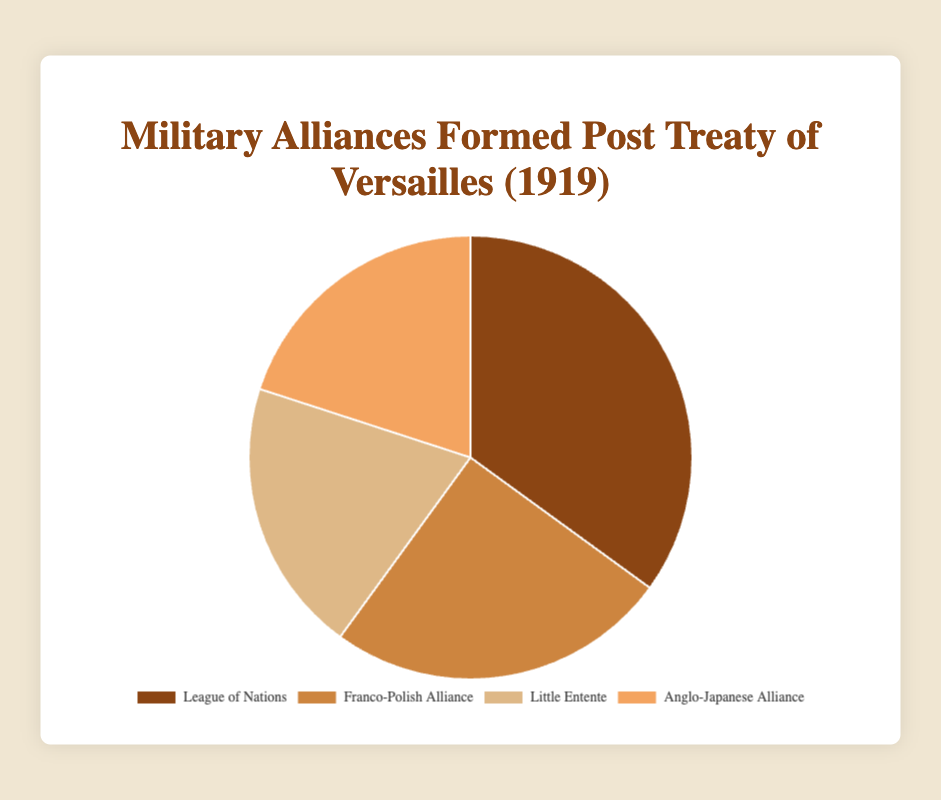What were the four military alliances formed post-Treaty of Versailles? The pie chart displays four alliances: League of Nations, Franco-Polish Alliance, Little Entente, and Anglo-Japanese Alliance, hence identifying the four alliances formed.
Answer: League of Nations, Franco-Polish Alliance, Little Entente, Anglo-Japanese Alliance Which alliance had the highest percentage of formations post-Treaty of Versailles? The largest section of the pie chart is for the League of Nations, indicated by the biggest segment in the pie chart.
Answer: League of Nations How did the percentages of Franco-Polish Alliance and Little Entente compare to each other? By looking at the pie chart, the segments for Franco-Polish Alliance and Little Entente show that Franco-Polish Alliance formed 25%, which is larger than Little Entente's 20%.
Answer: Franco-Polish Alliance was greater than Little Entente What is the combined percentage of the smaller alliances formed post-Treaty of Versailles? Summing the percentages of Little Entente and Anglo-Japanese Alliance (20% + 20%), which are the smaller segments, gives a combined percentage.
Answer: 40% How does the size of the League of Nations' segment visually differ from the Anglo-Japanese Alliance's segment? The segment for the League of Nations is larger than the Anglo-Japanese Alliance, indicating a higher percentage (35% compared to 20%).
Answer: The League of Nations' segment is larger Which two alliances each accounted for 20% of the formations post-Treaty of Versailles? Referring to the pie chart, both Little Entente and Anglo-Japanese Alliance's segments each represent 20%.
Answer: Little Entente and Anglo-Japanese Alliance How much larger is the percentage of the League of Nations compared to the Franco-Polish Alliance? Subtracting the percentage of Franco-Polish Alliance from that of the League of Nations (35% - 25%) gives the difference.
Answer: 10% If you were to merge the League of Nations and Franco-Polish Alliance, what percentage of the total alliances would they form combined? Adding the percentages of League of Nations (35%) and Franco-Polish Alliance (25%) gives the combined percentage.
Answer: 60% Which alliances combined form the same percentage as the League of Nations alone? Adding the percentages of Little Entente and Anglo-Japanese Alliance (20% + 20%) equals the League of Nations' 35%.
Answer: Little Entente and Anglo-Japanese Alliance What does the smallest percentage in this pie chart represent? By observing the smallest segment in the pie chart, which is equal among the bottom two categories, it represents Little Entente or Anglo-Japanese Alliance, both at 20%.
Answer: 20% (Little Entente or Anglo-Japanese Alliance) 